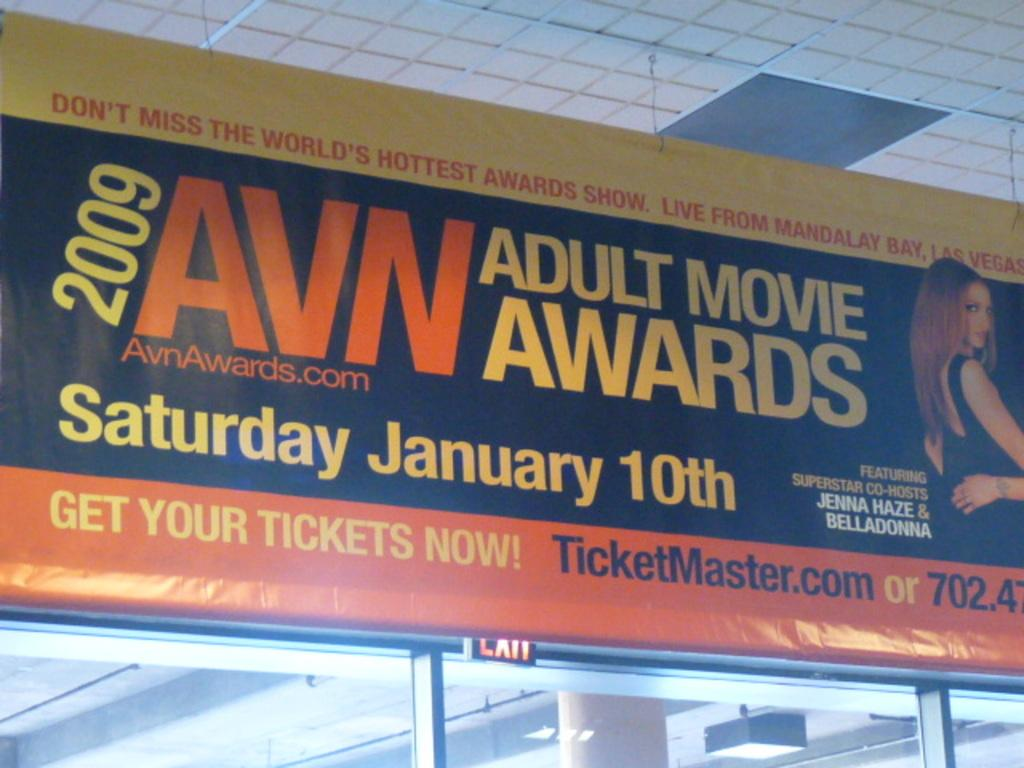<image>
Provide a brief description of the given image. A billboard for the 2009 AVN Adult Movie Awards. 